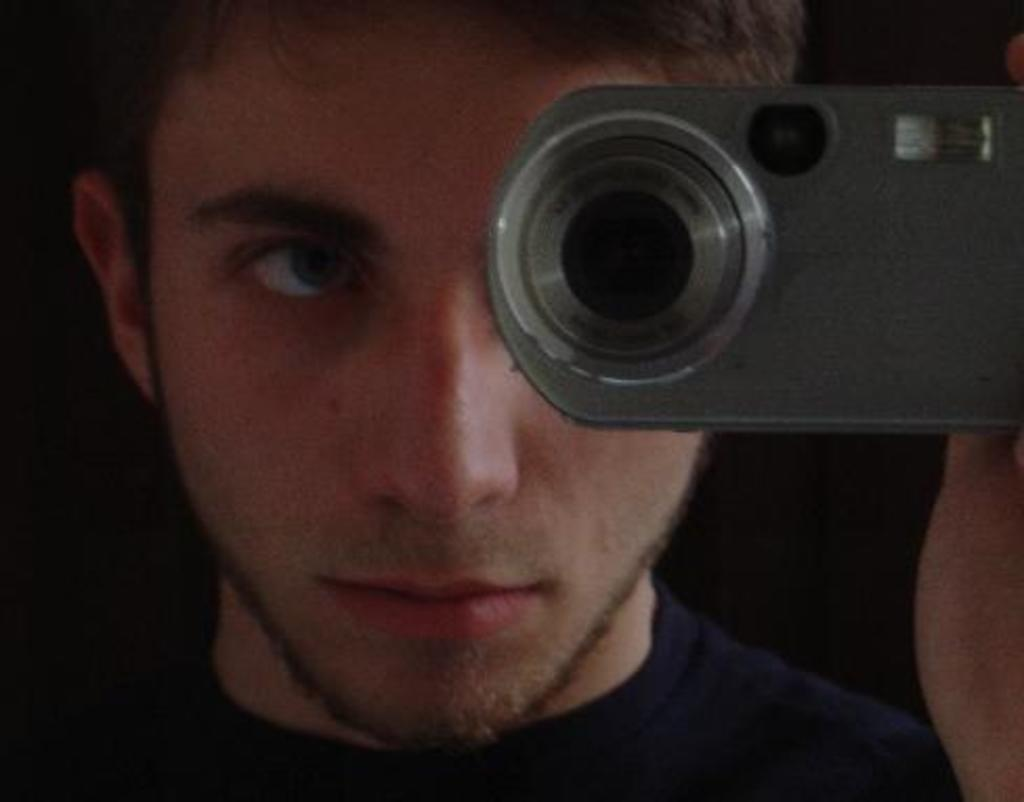What is the man in the image holding? The man is holding a camera in the image. What features does the camera have? The camera has a lens, a light, and a flash. What is the man wearing in the image? The man is wearing a blue T-shirt in the image. What type of rice can be seen in the nest in the image? There is no rice or nest present in the image; it features a man holding a camera. 